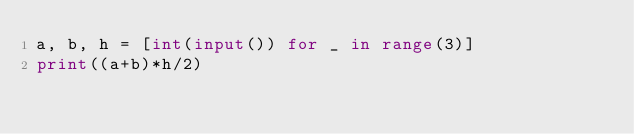Convert code to text. <code><loc_0><loc_0><loc_500><loc_500><_Python_>a, b, h = [int(input()) for _ in range(3)]
print((a+b)*h/2)
</code> 